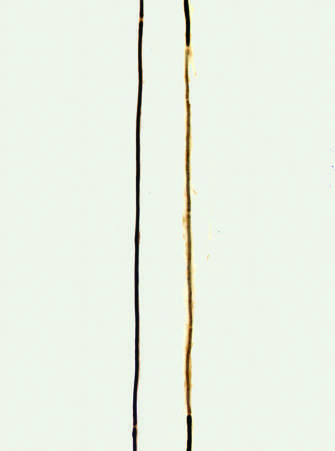does the right axon, by contrast, show a segment surrounded by a series of thinly myelinated internodes of uneven length flanked on both ends by normal thicker myelin internodes?
Answer the question using a single word or phrase. Yes 